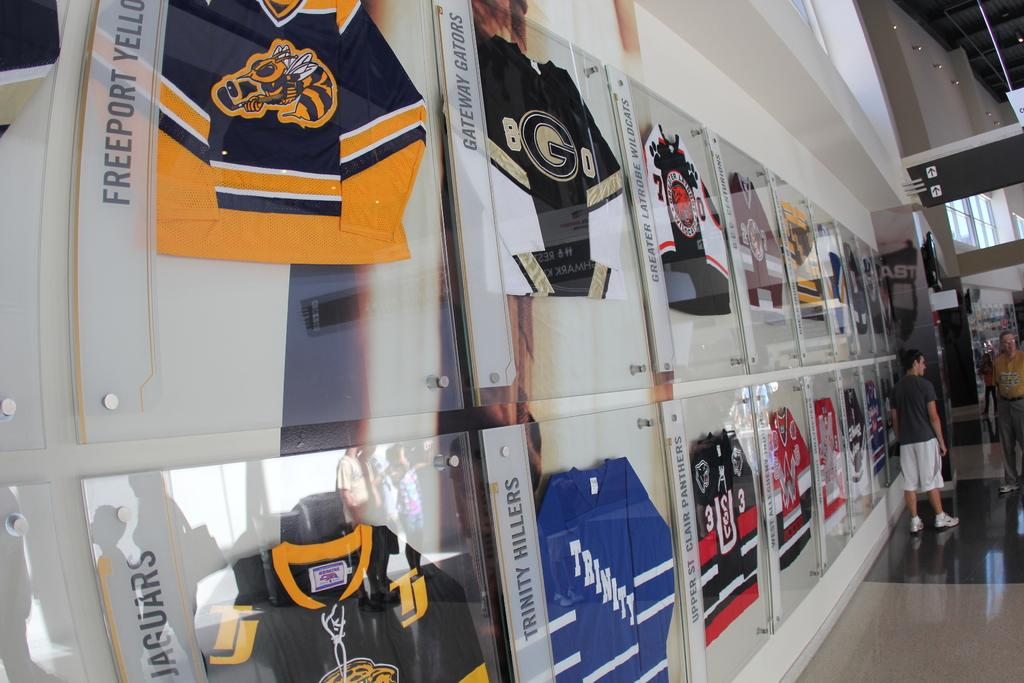<image>
Describe the image concisely. A wall of jerseys sit in a display case with one reading TRINITY 